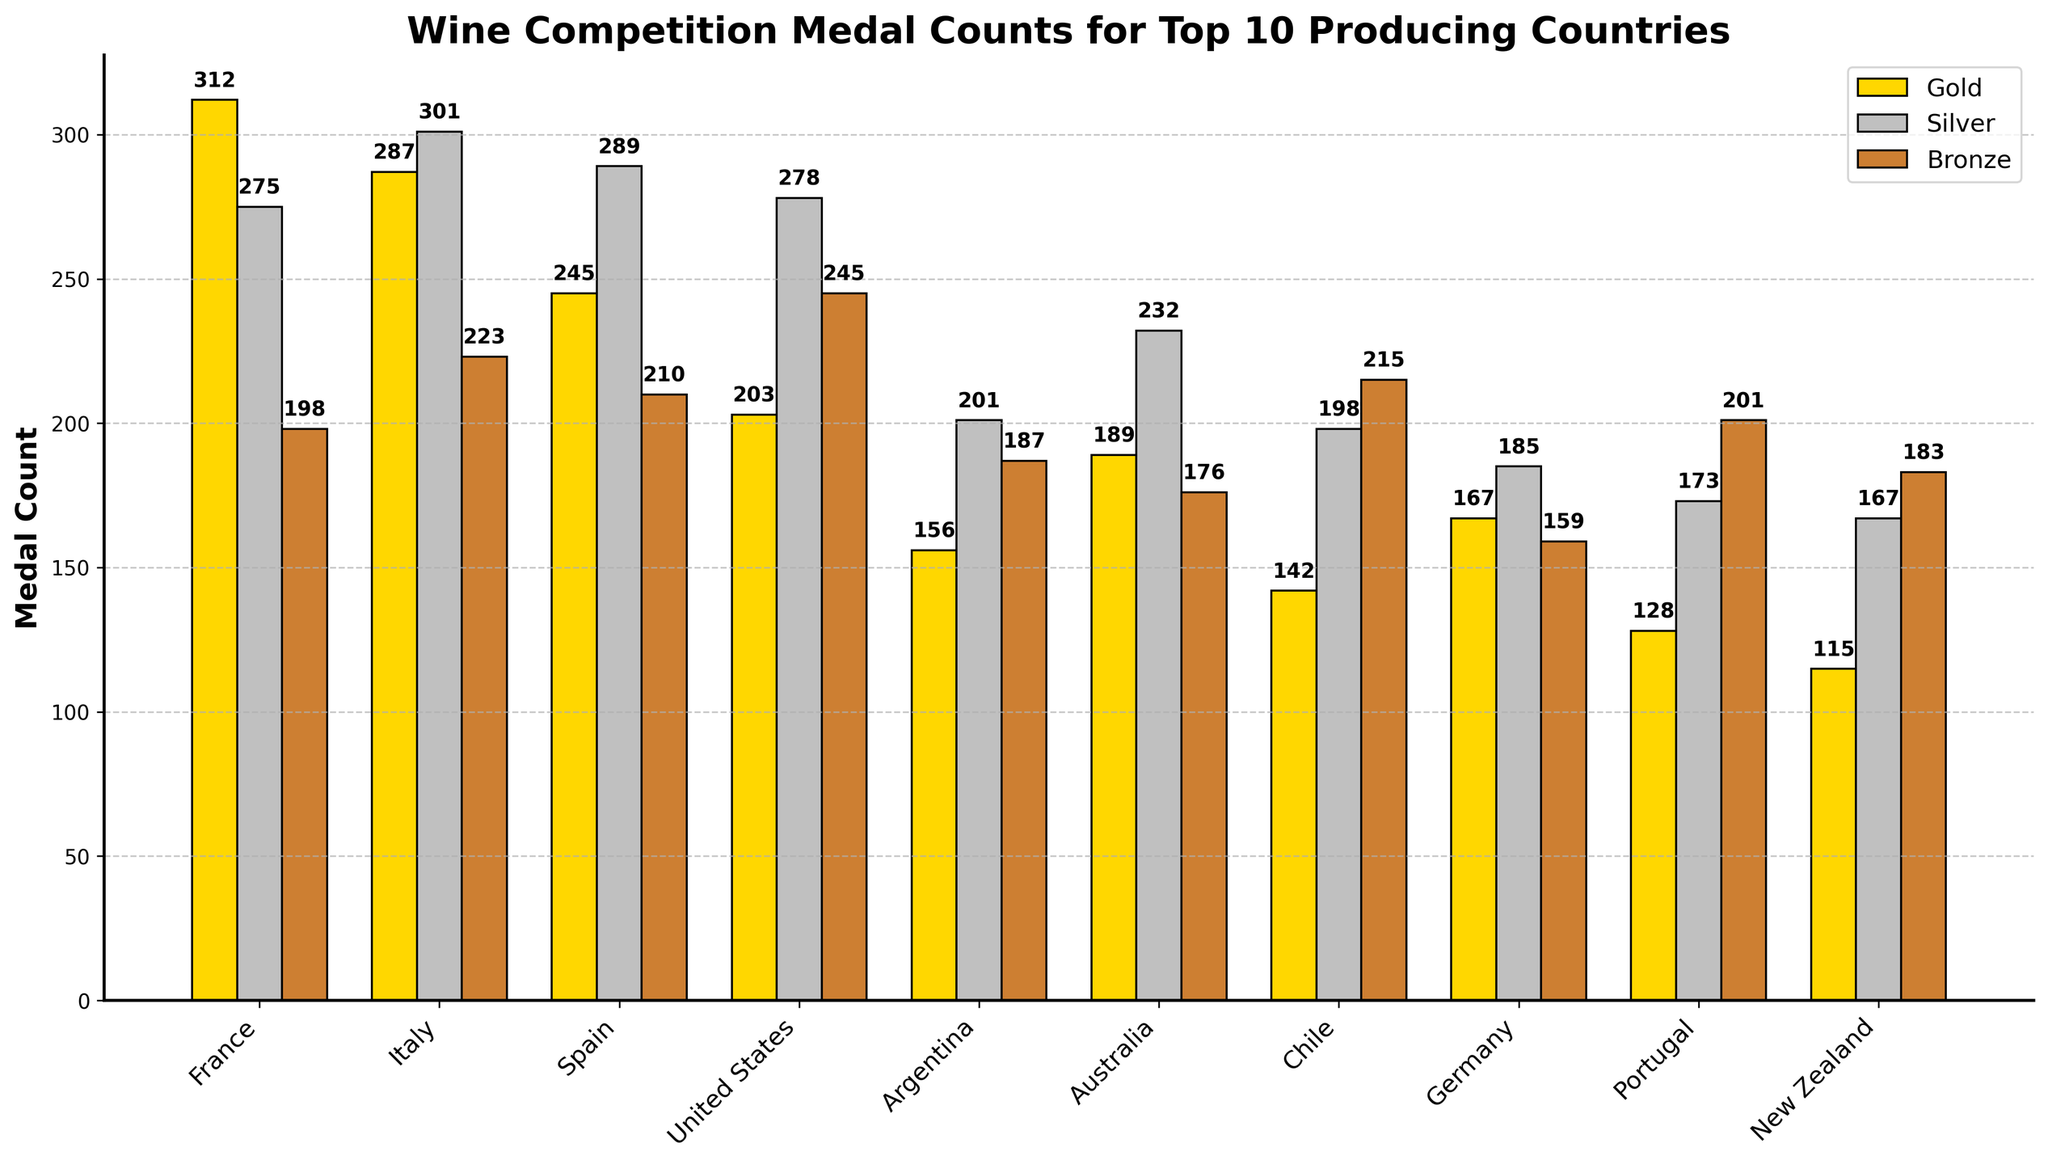What country has won the most gold medals? France's gold medal count is the highest at 312, which is visible from the tallest gold bar.
Answer: France Which country has the fewest bronze medals? Looking at the shortest bronze bar, New Zealand has the fewest bronze medals with 183.
Answer: New Zealand What is the total medal count for Italy? Italy's gold, silver, and bronze counts are 287, 301, and 223 respectively. Adding them together gives 287 + 301 + 223 = 811.
Answer: 811 Compare the total gold medals of France and Italy. Which country has more, and by how much? France's gold medal count is 312 and Italy's is 287. The difference is 312 - 287 = 25. France has 25 more gold medals than Italy.
Answer: France, 25 Which country has the highest silver medal count and how many more does it have compared to the country with the second-highest? Italy has the highest silver medal count at 301, followed by Spain with 289. The difference is 301 - 289 = 12.
Answer: Italy, 12 Are there any countries where the bronze medal count is higher than the gold and silver counts? For the U.S., bronze medals (245) are higher than gold (203) and silver (278).
Answer: United States Which country has the lowest total medal count, and what is that count? New Zealand's total is 115 (gold) + 167 (silver) + 183 (bronze) = 465, the lowest.
Answer: New Zealand, 465 How does Argentina's total medal count compare to Germany's? Argentina's totals are 156 (gold) + 201 (silver) + 187 (bronze) = 544. Germany's totals are 167 (gold) + 185 (silver) + 159 (bronze) = 511. Argentina has 544 - 511 = 33 more medals than Germany.
Answer: Argentina, 33 Which country has the second-highest number of bronze medals? The United States has the second-highest bronze medal count with 245, only behind Chile.
Answer: United States 